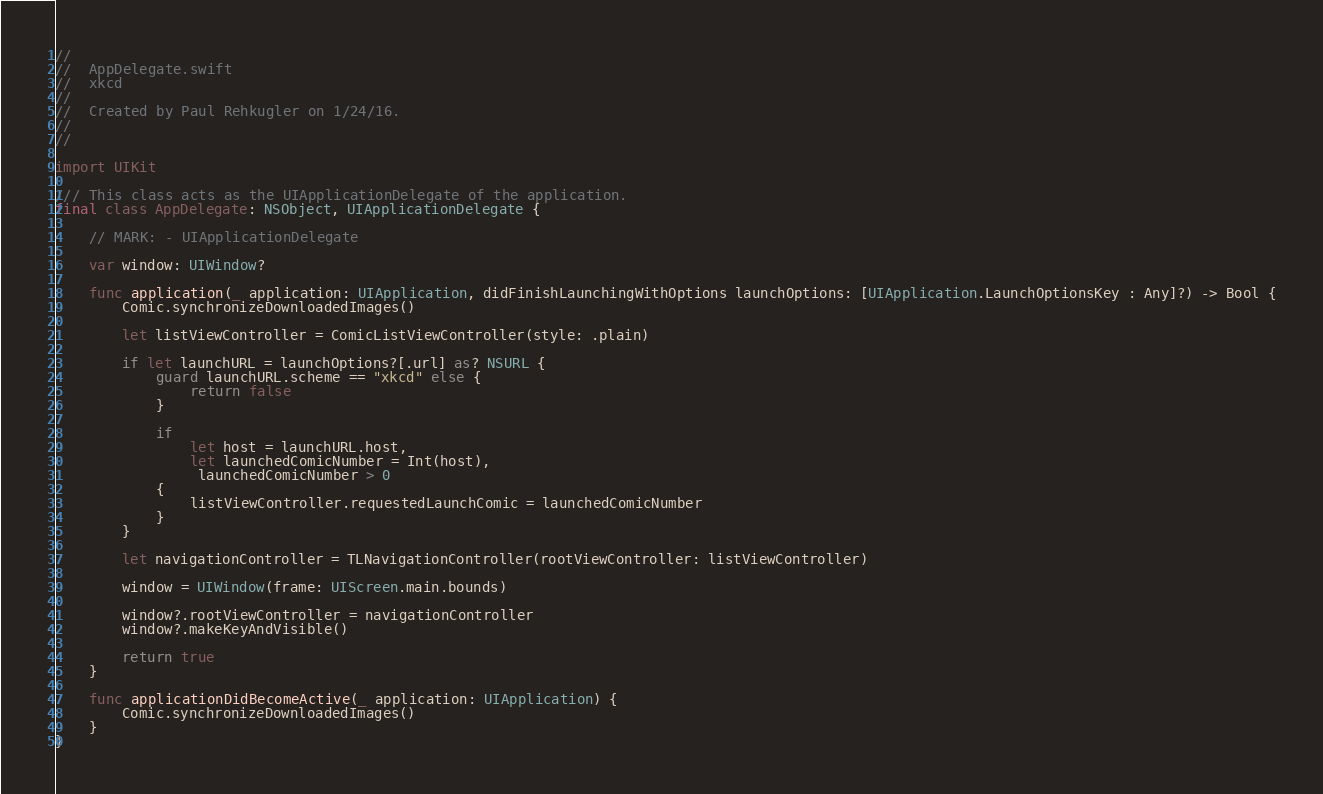Convert code to text. <code><loc_0><loc_0><loc_500><loc_500><_Swift_>//
//  AppDelegate.swift
//  xkcd
//
//  Created by Paul Rehkugler on 1/24/16.
//
//

import UIKit

/// This class acts as the UIApplicationDelegate of the application.
final class AppDelegate: NSObject, UIApplicationDelegate {

    // MARK: - UIApplicationDelegate

    var window: UIWindow?

	func application(_ application: UIApplication, didFinishLaunchingWithOptions launchOptions: [UIApplication.LaunchOptionsKey : Any]?) -> Bool {
		Comic.synchronizeDownloadedImages()

		let listViewController = ComicListViewController(style: .plain)

        if let launchURL = launchOptions?[.url] as? NSURL {
            guard launchURL.scheme == "xkcd" else {
                return false
            }

            if
                let host = launchURL.host,
                let launchedComicNumber = Int(host),
                 launchedComicNumber > 0
            {
                listViewController.requestedLaunchComic = launchedComicNumber
            }
        }

        let navigationController = TLNavigationController(rootViewController: listViewController)

		window = UIWindow(frame: UIScreen.main.bounds)

        window?.rootViewController = navigationController
        window?.makeKeyAndVisible()

        return true
    }
	
	func applicationDidBecomeActive(_ application: UIApplication) {
        Comic.synchronizeDownloadedImages()
    }
}
</code> 